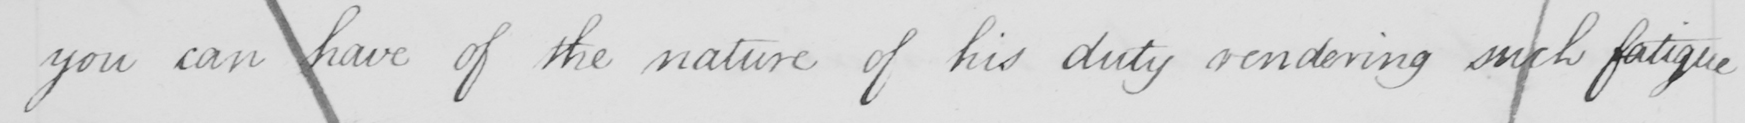Please provide the text content of this handwritten line. you can have of the nature of his duty rendering such fatigue 